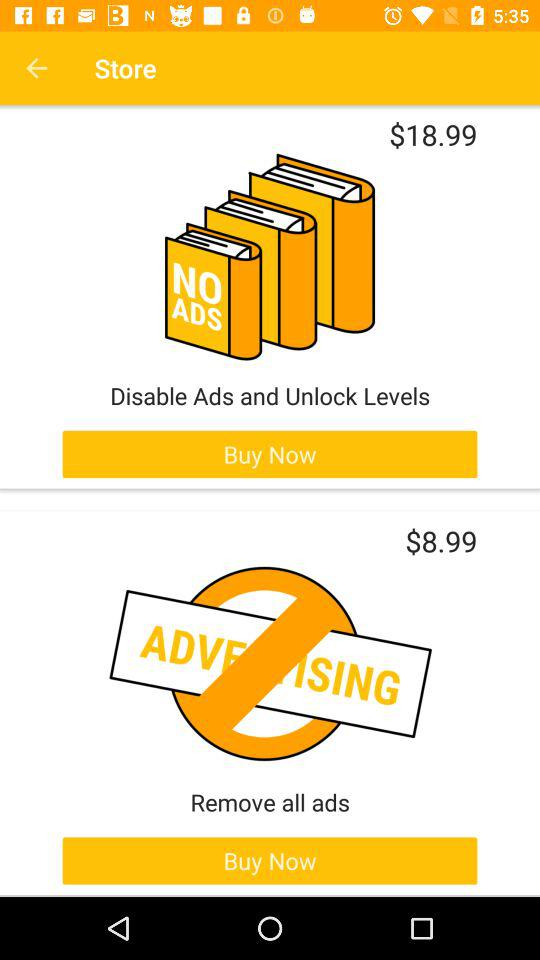How much does it cost to only unlock levels?
When the provided information is insufficient, respond with <no answer>. <no answer> 